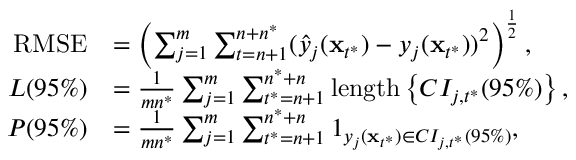<formula> <loc_0><loc_0><loc_500><loc_500>\begin{array} { r l } { R M S E } & { = \left ( { { \sum _ { j = 1 } ^ { m } \sum _ { t = n + 1 } ^ { n + n ^ { * } } ( \hat { y } _ { j } ( \mathbf x _ { t ^ { * } } ) - y _ { j } ( \mathbf x _ { t ^ { * } } ) ) ^ { 2 } } } \right ) ^ { \frac { 1 } { 2 } } , } \\ { L ( 9 5 \% ) } & { = \frac { 1 } { m n ^ { * } } \sum _ { j = 1 } ^ { m } \sum _ { t ^ { * } = n + 1 } ^ { n ^ { * } + n } l e n g t h \left \{ C I _ { j , t ^ { * } } ( 9 5 \% ) \right \} , } \\ { P ( 9 5 \% ) } & { = \frac { 1 } { m n ^ { * } } \sum _ { j = 1 } ^ { m } \sum _ { t ^ { * } = n + 1 } ^ { n ^ { * } + n } 1 _ { y _ { j } ( \mathbf x _ { t ^ { * } } ) \in C I _ { j , t ^ { * } } ( 9 5 \% ) } , } \end{array}</formula> 